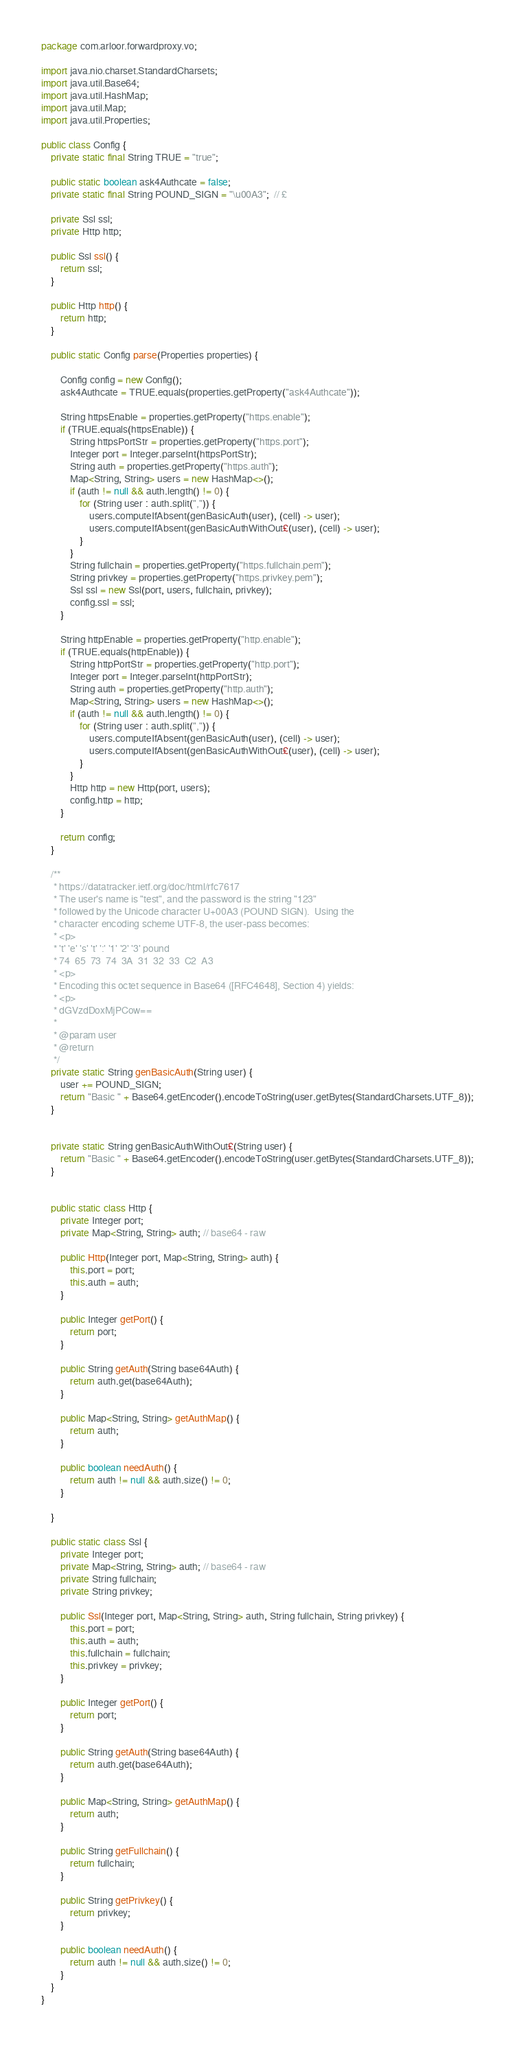<code> <loc_0><loc_0><loc_500><loc_500><_Java_>package com.arloor.forwardproxy.vo;

import java.nio.charset.StandardCharsets;
import java.util.Base64;
import java.util.HashMap;
import java.util.Map;
import java.util.Properties;

public class Config {
    private static final String TRUE = "true";

    public static boolean ask4Authcate = false;
    private static final String POUND_SIGN = "\u00A3";  // £

    private Ssl ssl;
    private Http http;

    public Ssl ssl() {
        return ssl;
    }

    public Http http() {
        return http;
    }

    public static Config parse(Properties properties) {

        Config config = new Config();
        ask4Authcate = TRUE.equals(properties.getProperty("ask4Authcate"));

        String httpsEnable = properties.getProperty("https.enable");
        if (TRUE.equals(httpsEnable)) {
            String httpsPortStr = properties.getProperty("https.port");
            Integer port = Integer.parseInt(httpsPortStr);
            String auth = properties.getProperty("https.auth");
            Map<String, String> users = new HashMap<>();
            if (auth != null && auth.length() != 0) {
                for (String user : auth.split(",")) {
                    users.computeIfAbsent(genBasicAuth(user), (cell) -> user);
                    users.computeIfAbsent(genBasicAuthWithOut£(user), (cell) -> user);
                }
            }
            String fullchain = properties.getProperty("https.fullchain.pem");
            String privkey = properties.getProperty("https.privkey.pem");
            Ssl ssl = new Ssl(port, users, fullchain, privkey);
            config.ssl = ssl;
        }

        String httpEnable = properties.getProperty("http.enable");
        if (TRUE.equals(httpEnable)) {
            String httpPortStr = properties.getProperty("http.port");
            Integer port = Integer.parseInt(httpPortStr);
            String auth = properties.getProperty("http.auth");
            Map<String, String> users = new HashMap<>();
            if (auth != null && auth.length() != 0) {
                for (String user : auth.split(",")) {
                    users.computeIfAbsent(genBasicAuth(user), (cell) -> user);
                    users.computeIfAbsent(genBasicAuthWithOut£(user), (cell) -> user);
                }
            }
            Http http = new Http(port, users);
            config.http = http;
        }

        return config;
    }

    /**
     * https://datatracker.ietf.org/doc/html/rfc7617
     * The user's name is "test", and the password is the string "123"
     * followed by the Unicode character U+00A3 (POUND SIGN).  Using the
     * character encoding scheme UTF-8, the user-pass becomes:
     * <p>
     * 't' 'e' 's' 't' ':' '1' '2' '3' pound
     * 74  65  73  74  3A  31  32  33  C2  A3
     * <p>
     * Encoding this octet sequence in Base64 ([RFC4648], Section 4) yields:
     * <p>
     * dGVzdDoxMjPCow==
     *
     * @param user
     * @return
     */
    private static String genBasicAuth(String user) {
        user += POUND_SIGN;
        return "Basic " + Base64.getEncoder().encodeToString(user.getBytes(StandardCharsets.UTF_8));
    }


    private static String genBasicAuthWithOut£(String user) {
        return "Basic " + Base64.getEncoder().encodeToString(user.getBytes(StandardCharsets.UTF_8));
    }


    public static class Http {
        private Integer port;
        private Map<String, String> auth; // base64 - raw

        public Http(Integer port, Map<String, String> auth) {
            this.port = port;
            this.auth = auth;
        }

        public Integer getPort() {
            return port;
        }

        public String getAuth(String base64Auth) {
            return auth.get(base64Auth);
        }

        public Map<String, String> getAuthMap() {
            return auth;
        }

        public boolean needAuth() {
            return auth != null && auth.size() != 0;
        }

    }

    public static class Ssl {
        private Integer port;
        private Map<String, String> auth; // base64 - raw
        private String fullchain;
        private String privkey;

        public Ssl(Integer port, Map<String, String> auth, String fullchain, String privkey) {
            this.port = port;
            this.auth = auth;
            this.fullchain = fullchain;
            this.privkey = privkey;
        }

        public Integer getPort() {
            return port;
        }

        public String getAuth(String base64Auth) {
            return auth.get(base64Auth);
        }

        public Map<String, String> getAuthMap() {
            return auth;
        }

        public String getFullchain() {
            return fullchain;
        }

        public String getPrivkey() {
            return privkey;
        }

        public boolean needAuth() {
            return auth != null && auth.size() != 0;
        }
    }
}
</code> 